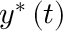Convert formula to latex. <formula><loc_0><loc_0><loc_500><loc_500>y ^ { \ast } \left ( t \right )</formula> 